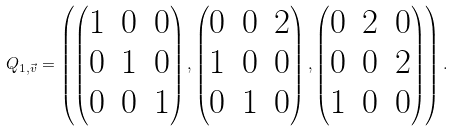Convert formula to latex. <formula><loc_0><loc_0><loc_500><loc_500>Q _ { 1 , \vec { v } } = \left ( \begin{pmatrix} 1 & 0 & 0 \\ 0 & 1 & 0 \\ 0 & 0 & 1 \\ \end{pmatrix} , \begin{pmatrix} 0 & 0 & 2 \\ 1 & 0 & 0 \\ 0 & 1 & 0 \\ \end{pmatrix} , \begin{pmatrix} 0 & 2 & 0 \\ 0 & 0 & 2 \\ 1 & 0 & 0 \end{pmatrix} \right ) .</formula> 